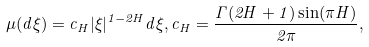<formula> <loc_0><loc_0><loc_500><loc_500>\mu ( d \xi ) = c _ { H } | \xi | ^ { 1 - 2 H } d \xi , c _ { H } = \frac { \Gamma ( 2 H + 1 ) \sin ( \pi H ) } { 2 \pi } ,</formula> 